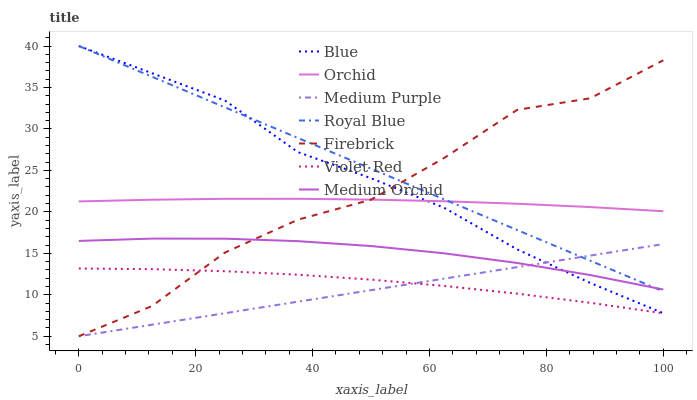Does Medium Purple have the minimum area under the curve?
Answer yes or no. Yes. Does Royal Blue have the maximum area under the curve?
Answer yes or no. Yes. Does Violet Red have the minimum area under the curve?
Answer yes or no. No. Does Violet Red have the maximum area under the curve?
Answer yes or no. No. Is Medium Purple the smoothest?
Answer yes or no. Yes. Is Firebrick the roughest?
Answer yes or no. Yes. Is Violet Red the smoothest?
Answer yes or no. No. Is Violet Red the roughest?
Answer yes or no. No. Does Firebrick have the lowest value?
Answer yes or no. Yes. Does Violet Red have the lowest value?
Answer yes or no. No. Does Royal Blue have the highest value?
Answer yes or no. Yes. Does Firebrick have the highest value?
Answer yes or no. No. Is Violet Red less than Medium Orchid?
Answer yes or no. Yes. Is Royal Blue greater than Violet Red?
Answer yes or no. Yes. Does Medium Purple intersect Blue?
Answer yes or no. Yes. Is Medium Purple less than Blue?
Answer yes or no. No. Is Medium Purple greater than Blue?
Answer yes or no. No. Does Violet Red intersect Medium Orchid?
Answer yes or no. No. 